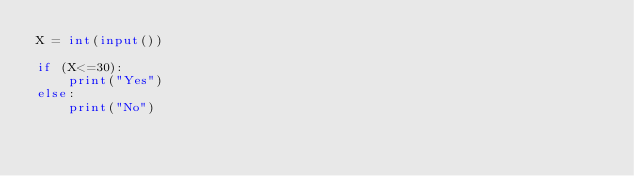<code> <loc_0><loc_0><loc_500><loc_500><_Python_>X = int(input())

if (X<=30):
    print("Yes")
else:
    print("No")
    </code> 